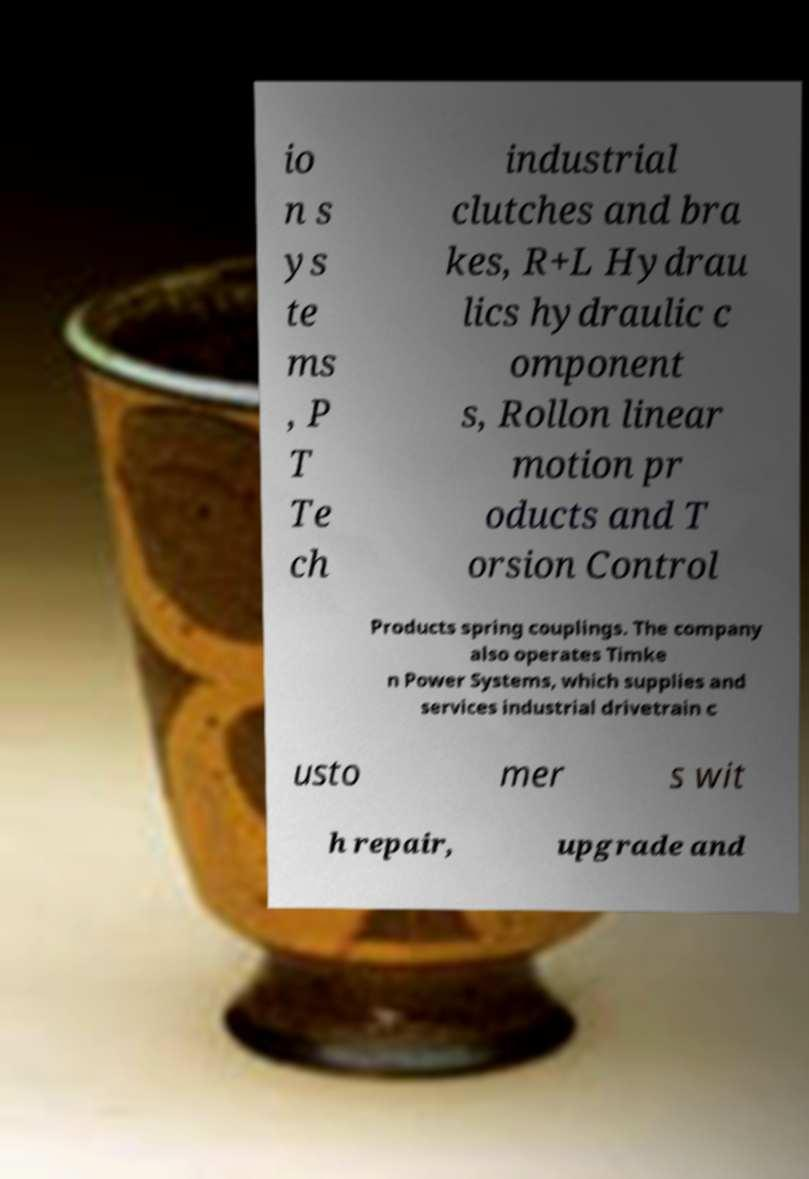For documentation purposes, I need the text within this image transcribed. Could you provide that? io n s ys te ms , P T Te ch industrial clutches and bra kes, R+L Hydrau lics hydraulic c omponent s, Rollon linear motion pr oducts and T orsion Control Products spring couplings. The company also operates Timke n Power Systems, which supplies and services industrial drivetrain c usto mer s wit h repair, upgrade and 